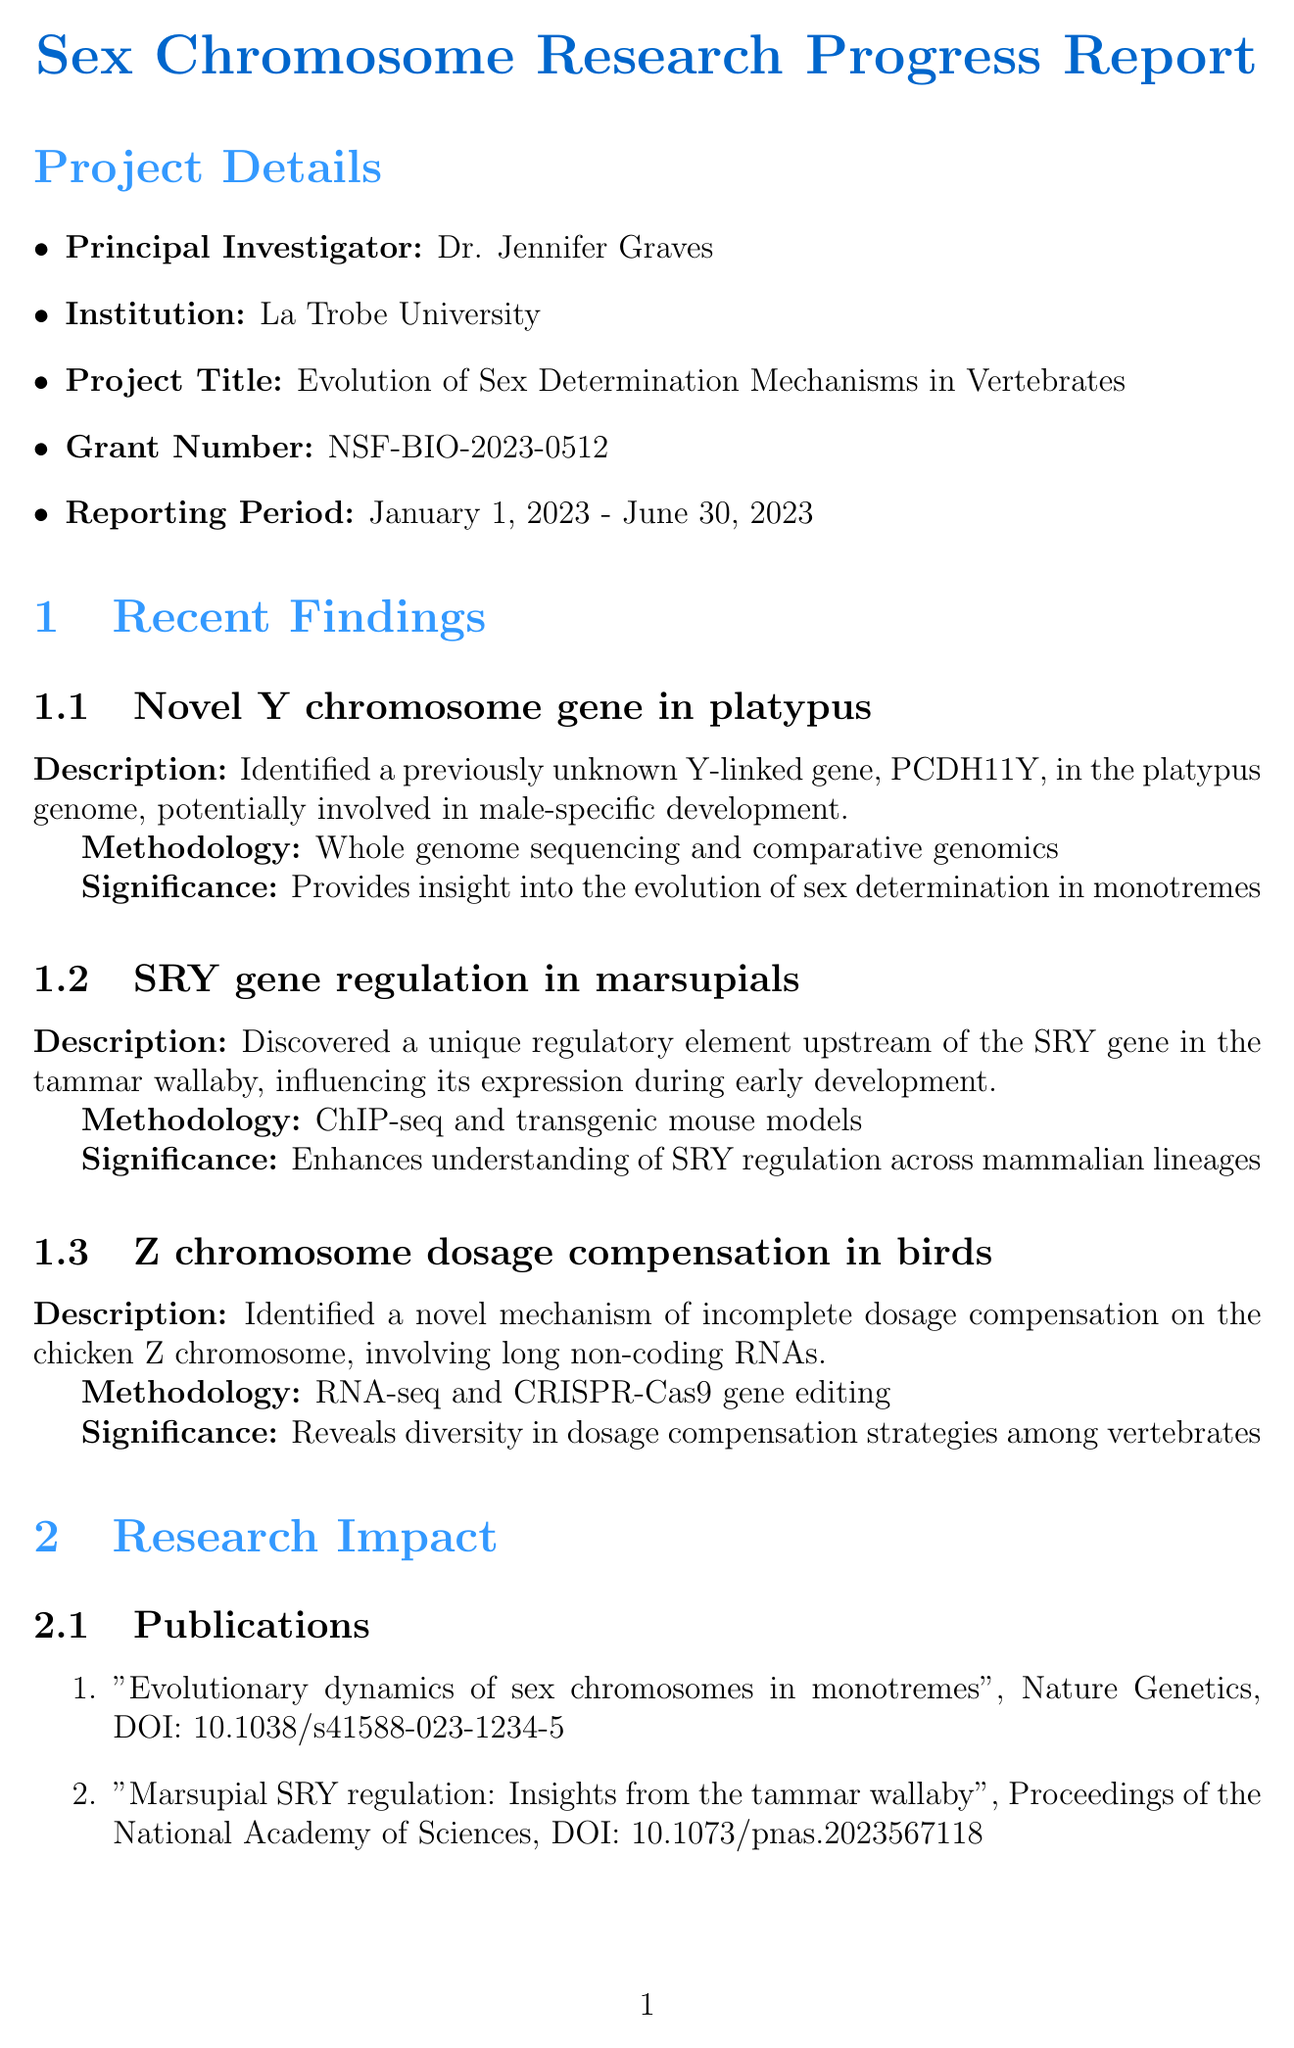What is the principal investigator's name? The principal investigator's name is stated as Dr. Jennifer Graves in the project details section of the document.
Answer: Dr. Jennifer Graves What is the project title? The project title is found in the project details section, detailing the focus of research on sex determination mechanisms.
Answer: Evolution of Sex Determination Mechanisms in Vertebrates What is the reporting period for the research? The reporting period is specified in the project details and indicates the timeframe of the research activities.
Answer: January 1, 2023 - June 30, 2023 What novel gene was identified in the platypus? The finding describes the identification of a Y-linked gene, crucial for understanding male-specific development in the platypus.
Answer: PCDH11Y What methodology was used to discover the SRY gene regulation in marsupials? The methodology used is detailed in the findings section, illustrating the techniques applied in the research.
Answer: ChIP-seq and transgenic mouse models How many publications are listed in the research impact section? The number of publications is indicated in the research impact section, summarizing the outputs of the ongoing research.
Answer: 2 What is the title of the conference where findings were presented? The conference title is mentioned in the research impact section, showcasing a platform for sharing research findings.
Answer: 23rd International Chromosome Conference What is the budget status of the project? The budget status is specified in the funding implications section, reflecting the financial health of the project.
Answer: On track What future direction involves CRISPR-Cas9 gene editing? The future directions section outlines various plans, one of which directly mentions the use of a specific technique in research.
Answer: Investigate the role of PCDH11Y in platypus sexual development using CRISPR-Cas9 gene editing 